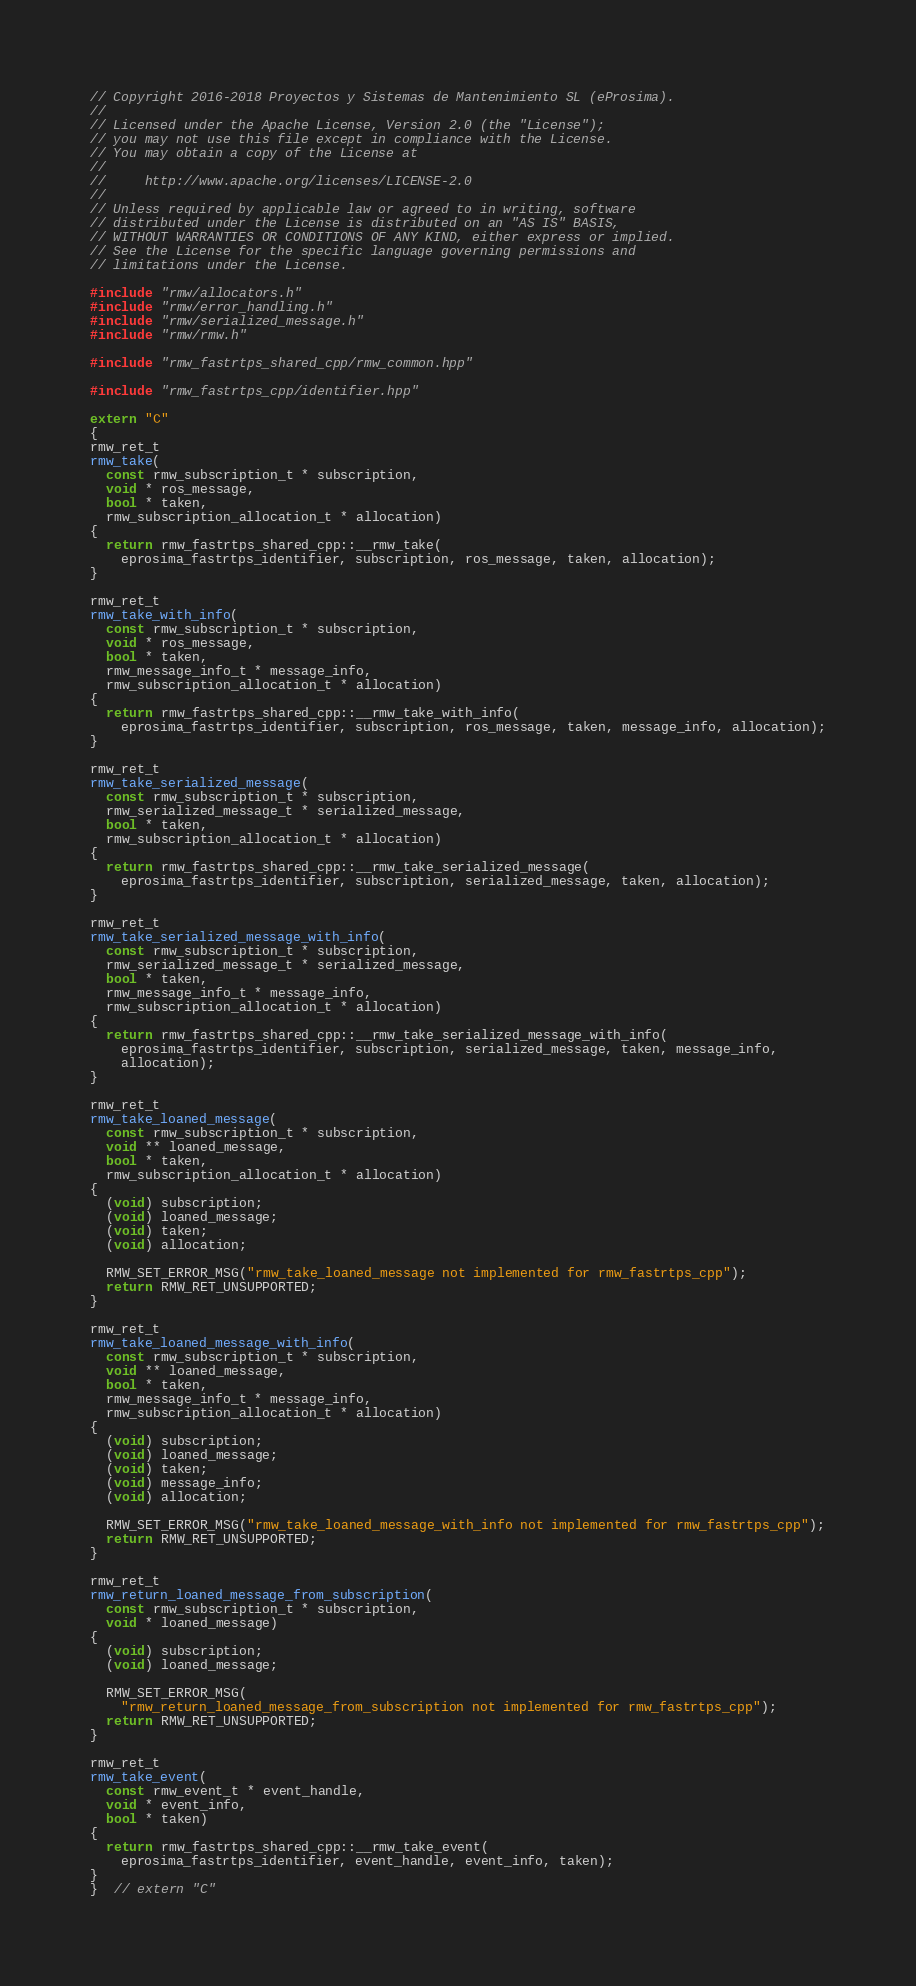Convert code to text. <code><loc_0><loc_0><loc_500><loc_500><_C++_>// Copyright 2016-2018 Proyectos y Sistemas de Mantenimiento SL (eProsima).
//
// Licensed under the Apache License, Version 2.0 (the "License");
// you may not use this file except in compliance with the License.
// You may obtain a copy of the License at
//
//     http://www.apache.org/licenses/LICENSE-2.0
//
// Unless required by applicable law or agreed to in writing, software
// distributed under the License is distributed on an "AS IS" BASIS,
// WITHOUT WARRANTIES OR CONDITIONS OF ANY KIND, either express or implied.
// See the License for the specific language governing permissions and
// limitations under the License.

#include "rmw/allocators.h"
#include "rmw/error_handling.h"
#include "rmw/serialized_message.h"
#include "rmw/rmw.h"

#include "rmw_fastrtps_shared_cpp/rmw_common.hpp"

#include "rmw_fastrtps_cpp/identifier.hpp"

extern "C"
{
rmw_ret_t
rmw_take(
  const rmw_subscription_t * subscription,
  void * ros_message,
  bool * taken,
  rmw_subscription_allocation_t * allocation)
{
  return rmw_fastrtps_shared_cpp::__rmw_take(
    eprosima_fastrtps_identifier, subscription, ros_message, taken, allocation);
}

rmw_ret_t
rmw_take_with_info(
  const rmw_subscription_t * subscription,
  void * ros_message,
  bool * taken,
  rmw_message_info_t * message_info,
  rmw_subscription_allocation_t * allocation)
{
  return rmw_fastrtps_shared_cpp::__rmw_take_with_info(
    eprosima_fastrtps_identifier, subscription, ros_message, taken, message_info, allocation);
}

rmw_ret_t
rmw_take_serialized_message(
  const rmw_subscription_t * subscription,
  rmw_serialized_message_t * serialized_message,
  bool * taken,
  rmw_subscription_allocation_t * allocation)
{
  return rmw_fastrtps_shared_cpp::__rmw_take_serialized_message(
    eprosima_fastrtps_identifier, subscription, serialized_message, taken, allocation);
}

rmw_ret_t
rmw_take_serialized_message_with_info(
  const rmw_subscription_t * subscription,
  rmw_serialized_message_t * serialized_message,
  bool * taken,
  rmw_message_info_t * message_info,
  rmw_subscription_allocation_t * allocation)
{
  return rmw_fastrtps_shared_cpp::__rmw_take_serialized_message_with_info(
    eprosima_fastrtps_identifier, subscription, serialized_message, taken, message_info,
    allocation);
}

rmw_ret_t
rmw_take_loaned_message(
  const rmw_subscription_t * subscription,
  void ** loaned_message,
  bool * taken,
  rmw_subscription_allocation_t * allocation)
{
  (void) subscription;
  (void) loaned_message;
  (void) taken;
  (void) allocation;

  RMW_SET_ERROR_MSG("rmw_take_loaned_message not implemented for rmw_fastrtps_cpp");
  return RMW_RET_UNSUPPORTED;
}

rmw_ret_t
rmw_take_loaned_message_with_info(
  const rmw_subscription_t * subscription,
  void ** loaned_message,
  bool * taken,
  rmw_message_info_t * message_info,
  rmw_subscription_allocation_t * allocation)
{
  (void) subscription;
  (void) loaned_message;
  (void) taken;
  (void) message_info;
  (void) allocation;

  RMW_SET_ERROR_MSG("rmw_take_loaned_message_with_info not implemented for rmw_fastrtps_cpp");
  return RMW_RET_UNSUPPORTED;
}

rmw_ret_t
rmw_return_loaned_message_from_subscription(
  const rmw_subscription_t * subscription,
  void * loaned_message)
{
  (void) subscription;
  (void) loaned_message;

  RMW_SET_ERROR_MSG(
    "rmw_return_loaned_message_from_subscription not implemented for rmw_fastrtps_cpp");
  return RMW_RET_UNSUPPORTED;
}

rmw_ret_t
rmw_take_event(
  const rmw_event_t * event_handle,
  void * event_info,
  bool * taken)
{
  return rmw_fastrtps_shared_cpp::__rmw_take_event(
    eprosima_fastrtps_identifier, event_handle, event_info, taken);
}
}  // extern "C"
</code> 